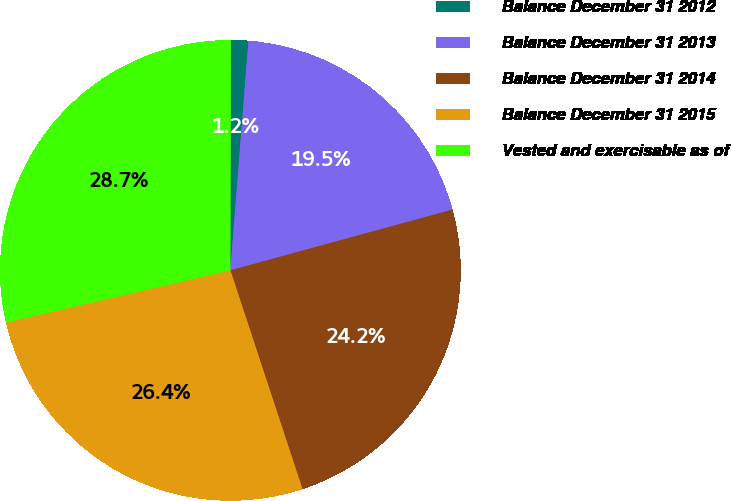<chart> <loc_0><loc_0><loc_500><loc_500><pie_chart><fcel>Balance December 31 2012<fcel>Balance December 31 2013<fcel>Balance December 31 2014<fcel>Balance December 31 2015<fcel>Vested and exercisable as of<nl><fcel>1.22%<fcel>19.5%<fcel>24.18%<fcel>26.43%<fcel>28.67%<nl></chart> 